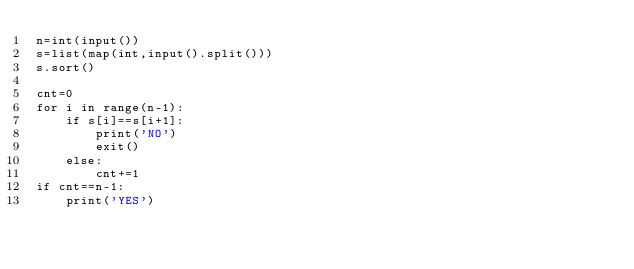<code> <loc_0><loc_0><loc_500><loc_500><_Python_>n=int(input())
s=list(map(int,input().split()))
s.sort()

cnt=0
for i in range(n-1):
    if s[i]==s[i+1]:
        print('NO')
        exit()
    else:
        cnt+=1
if cnt==n-1:            
    print('YES')
        </code> 